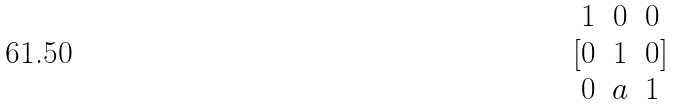Convert formula to latex. <formula><loc_0><loc_0><loc_500><loc_500>[ \begin{matrix} 1 & 0 & 0 \\ 0 & 1 & 0 \\ 0 & a & 1 \end{matrix} ]</formula> 